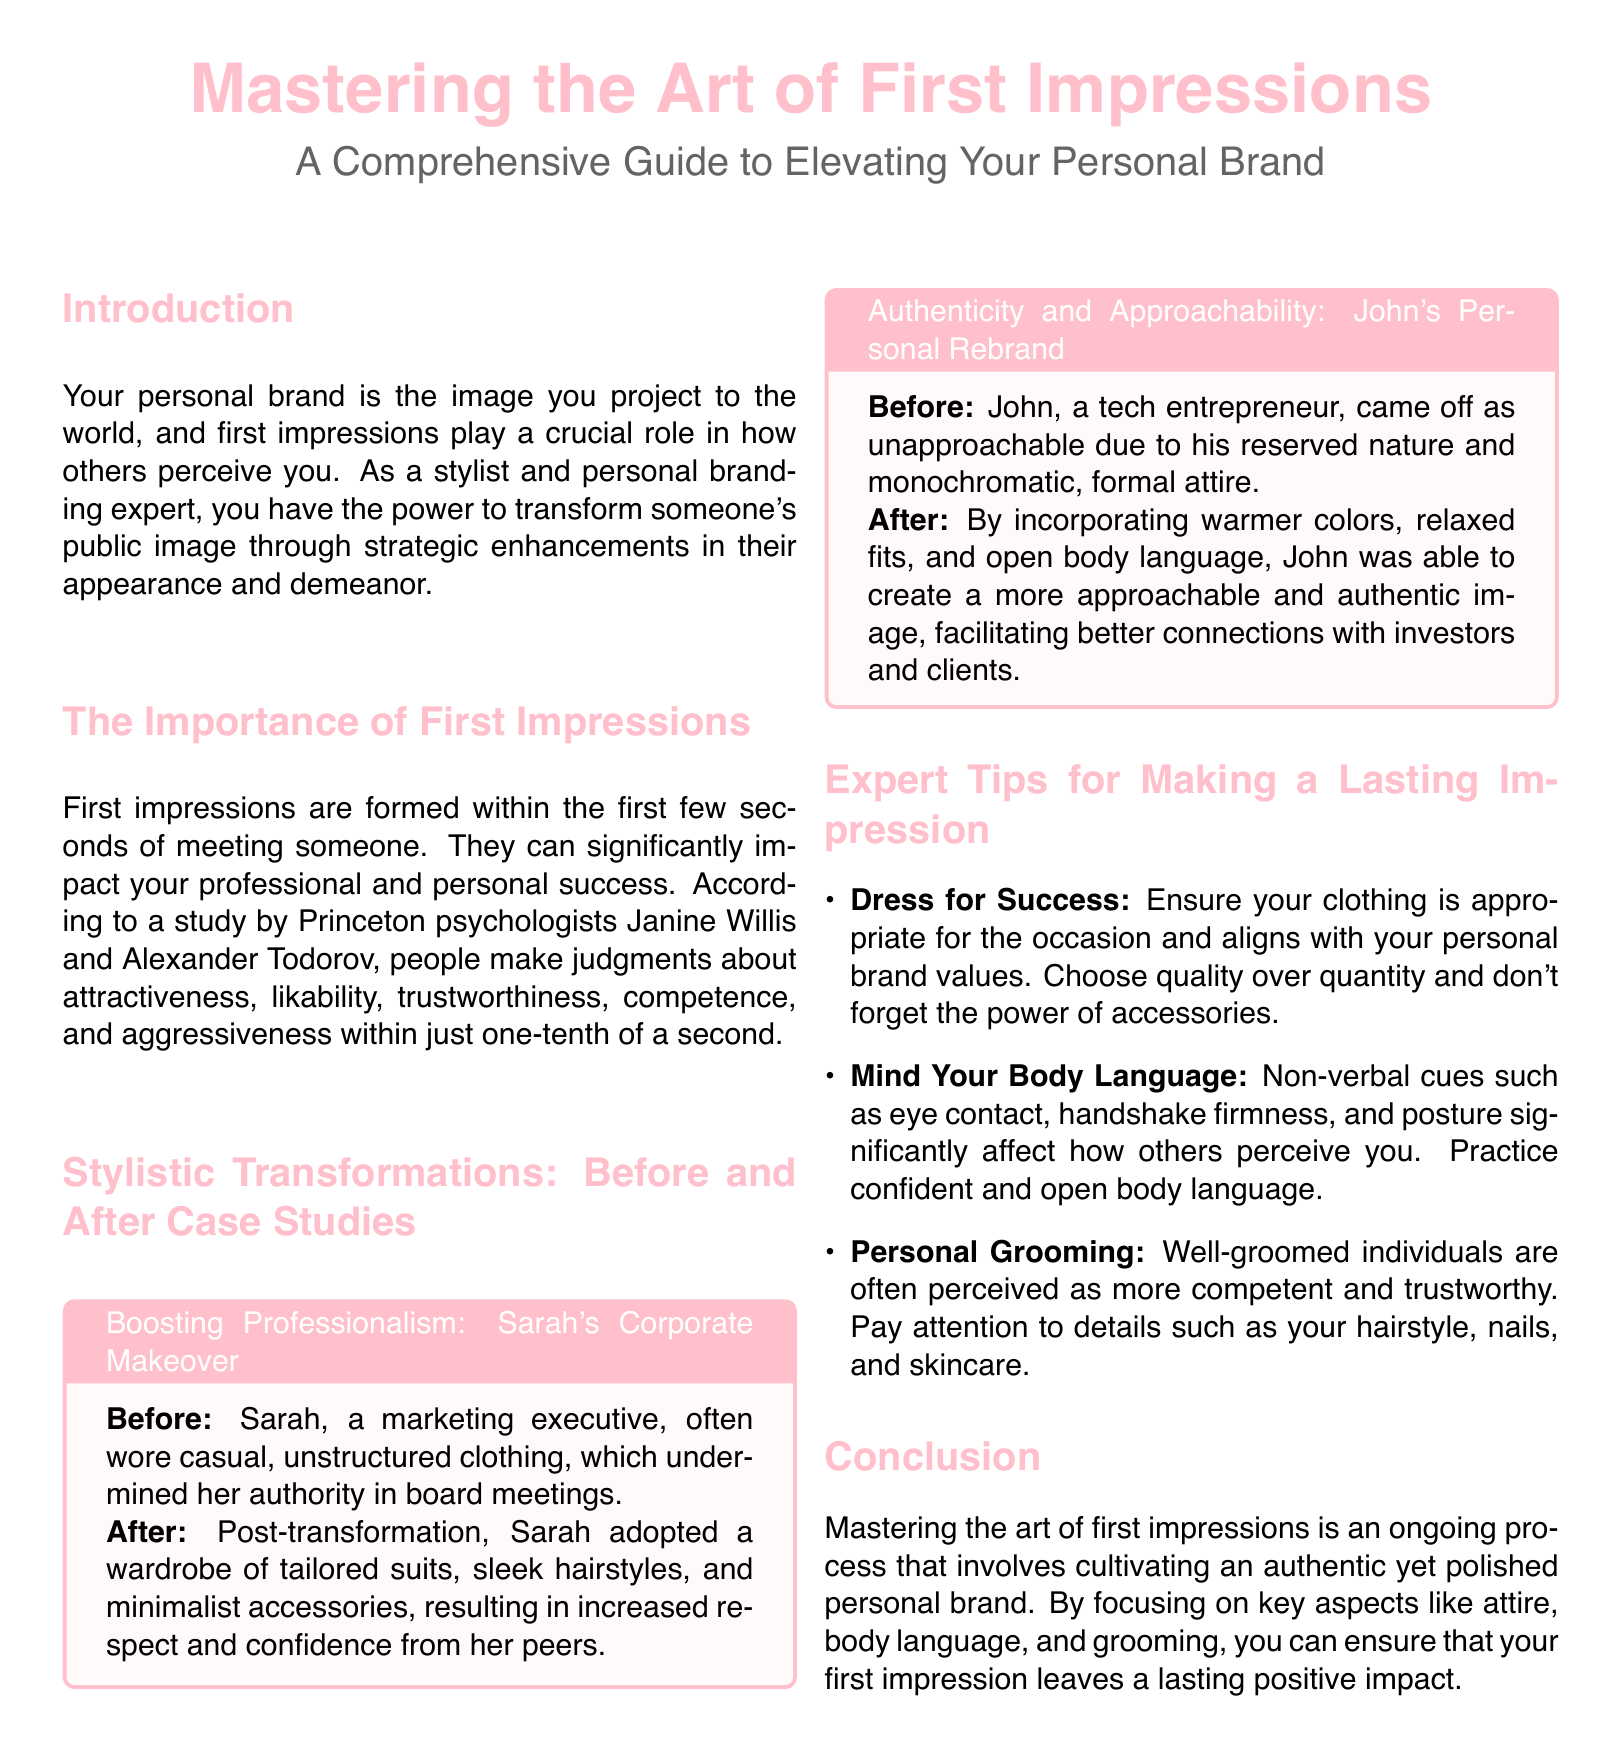What is the title of the document? The title of the document is prominently displayed at the top.
Answer: Mastering the Art of First Impressions What color is used for the main title? The color used for the main title is mentioned in the document.
Answer: brandpink What professional role does Sarah hold? Sarah's role is indicated in the case study provided.
Answer: marketing executive What type of clothing did Sarah wear before her makeover? The document specifies what Sarah wore before her transformation.
Answer: casual, unstructured clothing What does John incorporate in his new look to appear more approachable? John's transformation details are highlighted in his case study.
Answer: warmer colors, relaxed fits How many tips are provided for making a lasting impression? The tips section lists the number of tips available in that section.
Answer: three What is emphasized as important for non-verbal communication? The document notes specific aspects of non-verbal communication.
Answer: body language What is the overarching theme of the document? The theme of the document is summarized in the introduction and conclusion.
Answer: elevating your personal brand What is the purpose of personal grooming as mentioned in the document? The document explains the perception related to personal grooming.
Answer: perceived as more competent and trustworthy 